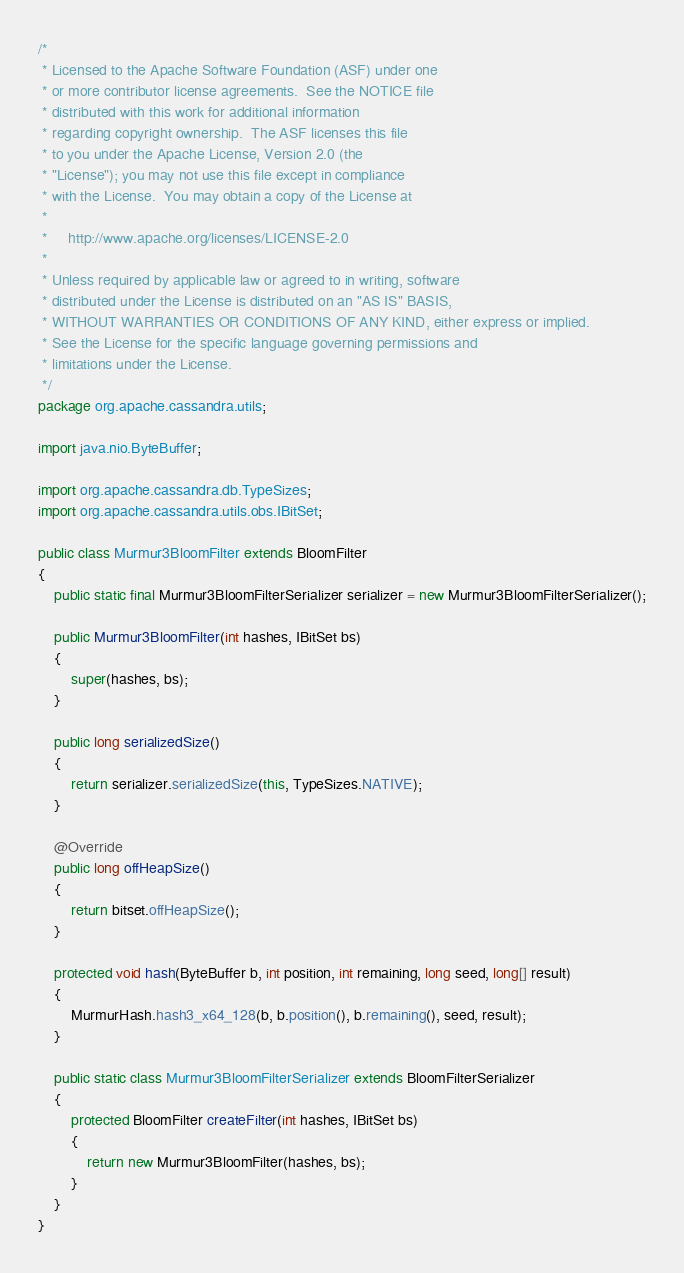Convert code to text. <code><loc_0><loc_0><loc_500><loc_500><_Java_>/*
 * Licensed to the Apache Software Foundation (ASF) under one
 * or more contributor license agreements.  See the NOTICE file
 * distributed with this work for additional information
 * regarding copyright ownership.  The ASF licenses this file
 * to you under the Apache License, Version 2.0 (the
 * "License"); you may not use this file except in compliance
 * with the License.  You may obtain a copy of the License at
 *
 *     http://www.apache.org/licenses/LICENSE-2.0
 *
 * Unless required by applicable law or agreed to in writing, software
 * distributed under the License is distributed on an "AS IS" BASIS,
 * WITHOUT WARRANTIES OR CONDITIONS OF ANY KIND, either express or implied.
 * See the License for the specific language governing permissions and
 * limitations under the License.
 */
package org.apache.cassandra.utils;

import java.nio.ByteBuffer;

import org.apache.cassandra.db.TypeSizes;
import org.apache.cassandra.utils.obs.IBitSet;

public class Murmur3BloomFilter extends BloomFilter
{
    public static final Murmur3BloomFilterSerializer serializer = new Murmur3BloomFilterSerializer();

    public Murmur3BloomFilter(int hashes, IBitSet bs)
    {
        super(hashes, bs);
    }

    public long serializedSize()
    {
        return serializer.serializedSize(this, TypeSizes.NATIVE);
    }

    @Override
    public long offHeapSize()
    {
        return bitset.offHeapSize();
    }

    protected void hash(ByteBuffer b, int position, int remaining, long seed, long[] result)
    {
        MurmurHash.hash3_x64_128(b, b.position(), b.remaining(), seed, result);
    }

    public static class Murmur3BloomFilterSerializer extends BloomFilterSerializer
    {
        protected BloomFilter createFilter(int hashes, IBitSet bs)
        {
            return new Murmur3BloomFilter(hashes, bs);
        }
    }
}</code> 